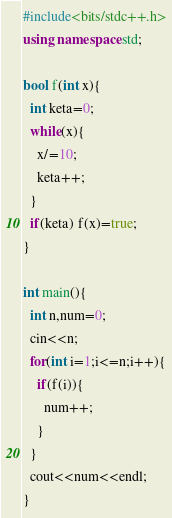<code> <loc_0><loc_0><loc_500><loc_500><_C++_>#include<bits/stdc++.h>
using namespace std;

bool f(int x){
  int keta=0;
  while(x){
    x/=10;
    keta++;
  }
  if(keta) f(x)=true;
}

int main(){
  int n,num=0;
  cin<<n;
  for(int i=1;i<=n;i++){
    if(f(i)){
      num++;
    }
  }
  cout<<num<<endl;
}</code> 